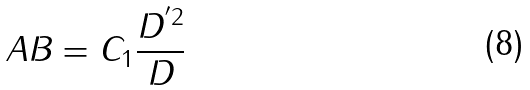<formula> <loc_0><loc_0><loc_500><loc_500>A B = C _ { 1 } \frac { D ^ { ^ { \prime } 2 } } D</formula> 